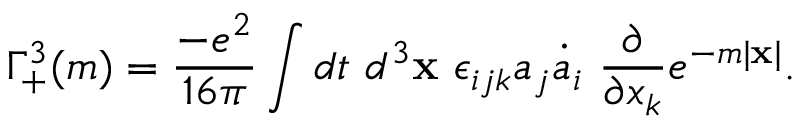<formula> <loc_0><loc_0><loc_500><loc_500>\Gamma _ { + } ^ { 3 } ( m ) = \frac { - e ^ { 2 } } { 1 6 \pi } \int d t d ^ { 3 } { x } \epsilon _ { i j k } a _ { j } \dot { a } _ { i } \frac { \partial } { \partial x _ { k } } e ^ { - m | { x } | } .</formula> 